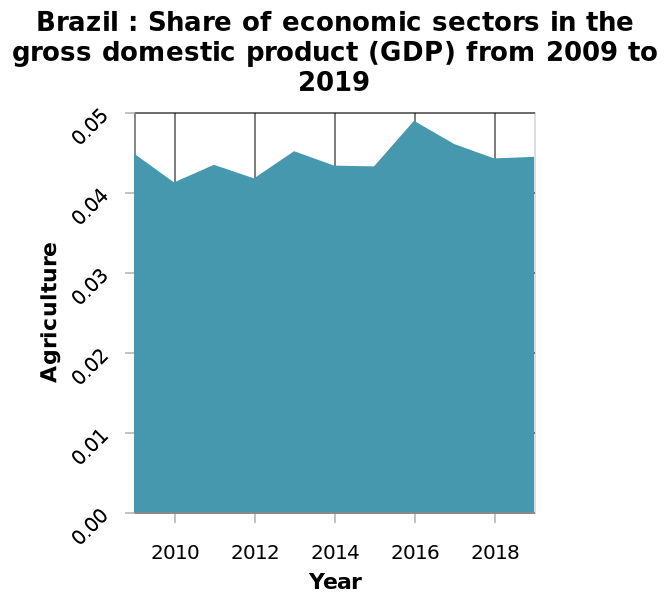<image>
please summary the statistics and relations of the chart from the above graph there was a peak in the economic sectors in 2016. Describe the following image in detail Brazil : Share of economic sectors in the gross domestic product (GDP) from 2009 to 2019 is a area diagram. Agriculture is defined as a linear scale of range 0.00 to 0.05 on the y-axis. A linear scale from 2010 to 2018 can be seen along the x-axis, marked Year. Was there a peak in the economic sectors in 2017? No.from the above graph there was a peak in the economic sectors in 2016. 